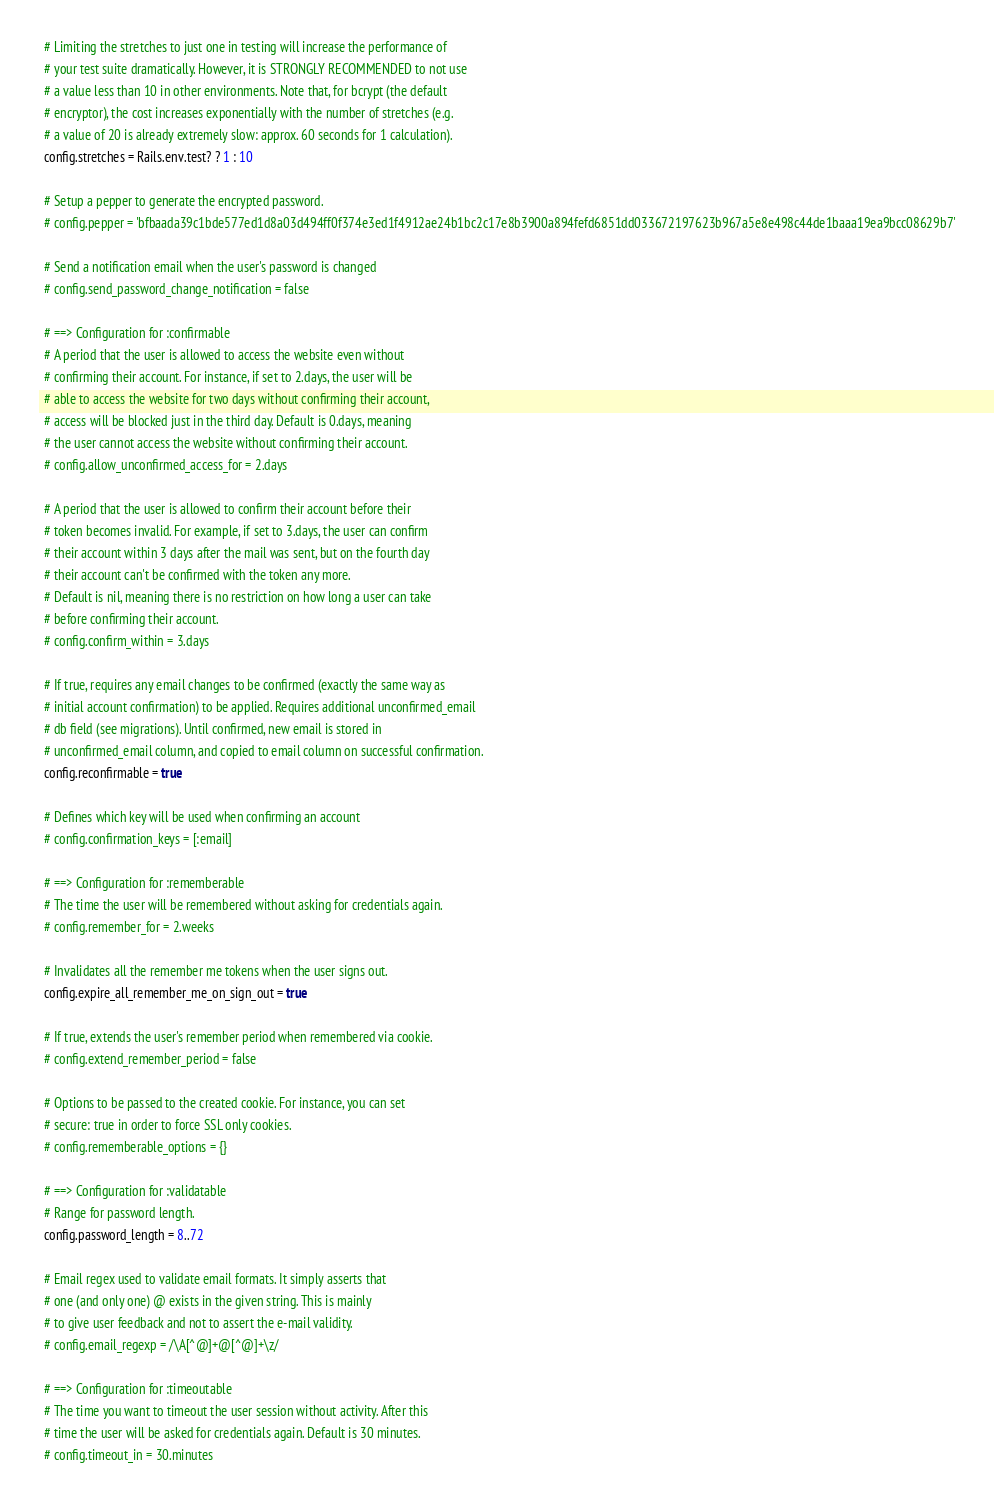<code> <loc_0><loc_0><loc_500><loc_500><_Ruby_>  # Limiting the stretches to just one in testing will increase the performance of
  # your test suite dramatically. However, it is STRONGLY RECOMMENDED to not use
  # a value less than 10 in other environments. Note that, for bcrypt (the default
  # encryptor), the cost increases exponentially with the number of stretches (e.g.
  # a value of 20 is already extremely slow: approx. 60 seconds for 1 calculation).
  config.stretches = Rails.env.test? ? 1 : 10

  # Setup a pepper to generate the encrypted password.
  # config.pepper = 'bfbaada39c1bde577ed1d8a03d494ff0f374e3ed1f4912ae24b1bc2c17e8b3900a894fefd6851dd033672197623b967a5e8e498c44de1baaa19ea9bcc08629b7'

  # Send a notification email when the user's password is changed
  # config.send_password_change_notification = false

  # ==> Configuration for :confirmable
  # A period that the user is allowed to access the website even without
  # confirming their account. For instance, if set to 2.days, the user will be
  # able to access the website for two days without confirming their account,
  # access will be blocked just in the third day. Default is 0.days, meaning
  # the user cannot access the website without confirming their account.
  # config.allow_unconfirmed_access_for = 2.days

  # A period that the user is allowed to confirm their account before their
  # token becomes invalid. For example, if set to 3.days, the user can confirm
  # their account within 3 days after the mail was sent, but on the fourth day
  # their account can't be confirmed with the token any more.
  # Default is nil, meaning there is no restriction on how long a user can take
  # before confirming their account.
  # config.confirm_within = 3.days

  # If true, requires any email changes to be confirmed (exactly the same way as
  # initial account confirmation) to be applied. Requires additional unconfirmed_email
  # db field (see migrations). Until confirmed, new email is stored in
  # unconfirmed_email column, and copied to email column on successful confirmation.
  config.reconfirmable = true

  # Defines which key will be used when confirming an account
  # config.confirmation_keys = [:email]

  # ==> Configuration for :rememberable
  # The time the user will be remembered without asking for credentials again.
  # config.remember_for = 2.weeks

  # Invalidates all the remember me tokens when the user signs out.
  config.expire_all_remember_me_on_sign_out = true

  # If true, extends the user's remember period when remembered via cookie.
  # config.extend_remember_period = false

  # Options to be passed to the created cookie. For instance, you can set
  # secure: true in order to force SSL only cookies.
  # config.rememberable_options = {}

  # ==> Configuration for :validatable
  # Range for password length.
  config.password_length = 8..72

  # Email regex used to validate email formats. It simply asserts that
  # one (and only one) @ exists in the given string. This is mainly
  # to give user feedback and not to assert the e-mail validity.
  # config.email_regexp = /\A[^@]+@[^@]+\z/

  # ==> Configuration for :timeoutable
  # The time you want to timeout the user session without activity. After this
  # time the user will be asked for credentials again. Default is 30 minutes.
  # config.timeout_in = 30.minutes
</code> 